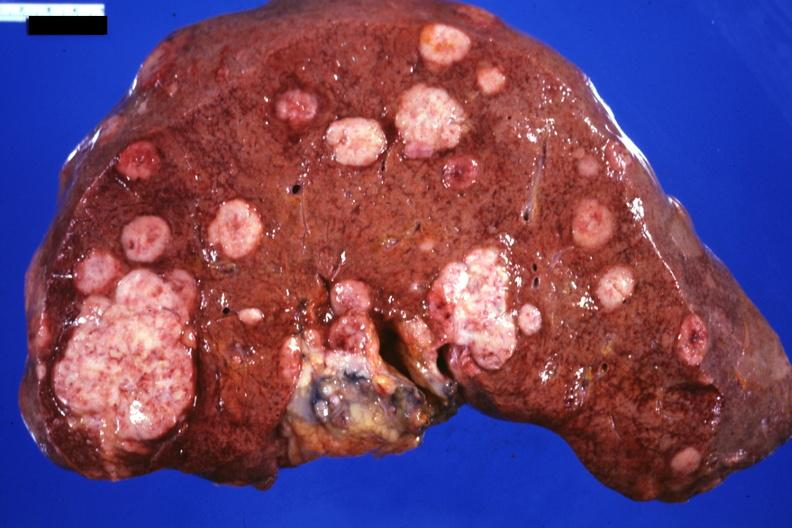s metastatic carcinoma prostate present?
Answer the question using a single word or phrase. No 